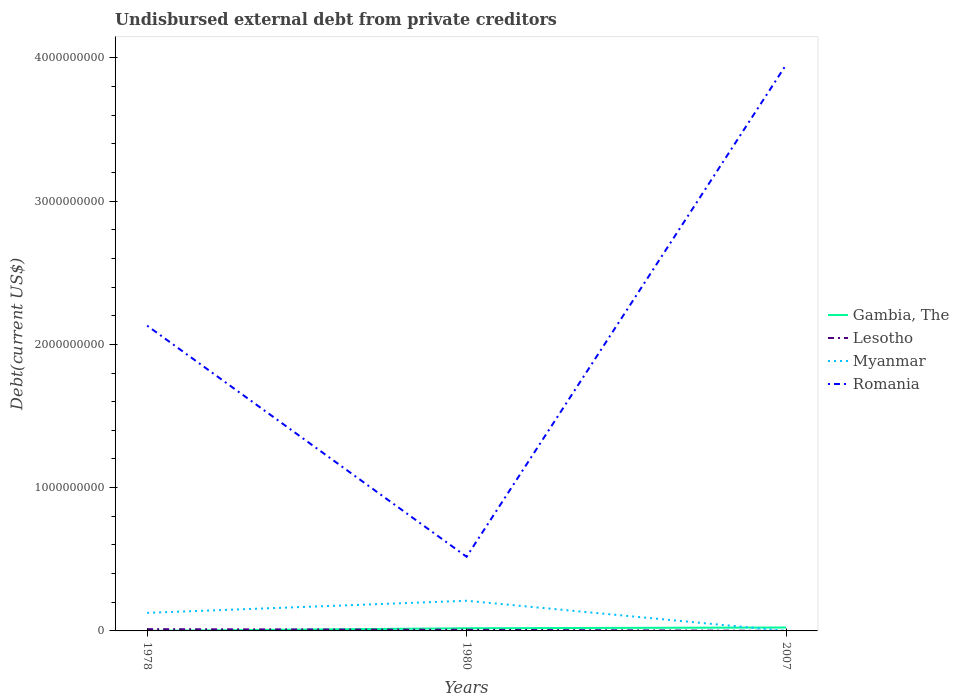How many different coloured lines are there?
Give a very brief answer. 4. Does the line corresponding to Myanmar intersect with the line corresponding to Lesotho?
Offer a terse response. Yes. Is the number of lines equal to the number of legend labels?
Offer a terse response. Yes. Across all years, what is the maximum total debt in Gambia, The?
Your response must be concise. 4.86e+05. In which year was the total debt in Lesotho maximum?
Offer a very short reply. 2007. What is the total total debt in Gambia, The in the graph?
Give a very brief answer. -2.34e+07. What is the difference between the highest and the second highest total debt in Lesotho?
Keep it short and to the point. 1.19e+07. Is the total debt in Gambia, The strictly greater than the total debt in Romania over the years?
Give a very brief answer. Yes. How many lines are there?
Keep it short and to the point. 4. What is the difference between two consecutive major ticks on the Y-axis?
Your response must be concise. 1.00e+09. Are the values on the major ticks of Y-axis written in scientific E-notation?
Keep it short and to the point. No. Where does the legend appear in the graph?
Your response must be concise. Center right. How many legend labels are there?
Keep it short and to the point. 4. How are the legend labels stacked?
Provide a short and direct response. Vertical. What is the title of the graph?
Your response must be concise. Undisbursed external debt from private creditors. What is the label or title of the X-axis?
Give a very brief answer. Years. What is the label or title of the Y-axis?
Provide a short and direct response. Debt(current US$). What is the Debt(current US$) in Gambia, The in 1978?
Your answer should be very brief. 4.86e+05. What is the Debt(current US$) of Lesotho in 1978?
Offer a terse response. 1.23e+07. What is the Debt(current US$) of Myanmar in 1978?
Give a very brief answer. 1.26e+08. What is the Debt(current US$) in Romania in 1978?
Make the answer very short. 2.13e+09. What is the Debt(current US$) in Gambia, The in 1980?
Provide a succinct answer. 1.86e+07. What is the Debt(current US$) in Myanmar in 1980?
Make the answer very short. 2.10e+08. What is the Debt(current US$) in Romania in 1980?
Your answer should be very brief. 5.18e+08. What is the Debt(current US$) in Gambia, The in 2007?
Provide a succinct answer. 2.39e+07. What is the Debt(current US$) in Lesotho in 2007?
Your answer should be very brief. 4.05e+05. What is the Debt(current US$) of Myanmar in 2007?
Your answer should be very brief. 4.70e+04. What is the Debt(current US$) in Romania in 2007?
Your answer should be compact. 3.95e+09. Across all years, what is the maximum Debt(current US$) in Gambia, The?
Keep it short and to the point. 2.39e+07. Across all years, what is the maximum Debt(current US$) of Lesotho?
Your response must be concise. 1.23e+07. Across all years, what is the maximum Debt(current US$) in Myanmar?
Offer a very short reply. 2.10e+08. Across all years, what is the maximum Debt(current US$) of Romania?
Keep it short and to the point. 3.95e+09. Across all years, what is the minimum Debt(current US$) of Gambia, The?
Your answer should be compact. 4.86e+05. Across all years, what is the minimum Debt(current US$) in Lesotho?
Keep it short and to the point. 4.05e+05. Across all years, what is the minimum Debt(current US$) of Myanmar?
Your answer should be compact. 4.70e+04. Across all years, what is the minimum Debt(current US$) in Romania?
Offer a very short reply. 5.18e+08. What is the total Debt(current US$) in Gambia, The in the graph?
Make the answer very short. 4.30e+07. What is the total Debt(current US$) in Lesotho in the graph?
Your response must be concise. 2.07e+07. What is the total Debt(current US$) of Myanmar in the graph?
Your answer should be very brief. 3.37e+08. What is the total Debt(current US$) of Romania in the graph?
Offer a terse response. 6.60e+09. What is the difference between the Debt(current US$) of Gambia, The in 1978 and that in 1980?
Keep it short and to the point. -1.81e+07. What is the difference between the Debt(current US$) of Lesotho in 1978 and that in 1980?
Provide a short and direct response. 4.29e+06. What is the difference between the Debt(current US$) in Myanmar in 1978 and that in 1980?
Provide a succinct answer. -8.45e+07. What is the difference between the Debt(current US$) of Romania in 1978 and that in 1980?
Make the answer very short. 1.61e+09. What is the difference between the Debt(current US$) of Gambia, The in 1978 and that in 2007?
Your response must be concise. -2.34e+07. What is the difference between the Debt(current US$) of Lesotho in 1978 and that in 2007?
Your answer should be very brief. 1.19e+07. What is the difference between the Debt(current US$) in Myanmar in 1978 and that in 2007?
Make the answer very short. 1.26e+08. What is the difference between the Debt(current US$) of Romania in 1978 and that in 2007?
Offer a terse response. -1.82e+09. What is the difference between the Debt(current US$) of Gambia, The in 1980 and that in 2007?
Provide a succinct answer. -5.34e+06. What is the difference between the Debt(current US$) in Lesotho in 1980 and that in 2007?
Your answer should be compact. 7.60e+06. What is the difference between the Debt(current US$) in Myanmar in 1980 and that in 2007?
Give a very brief answer. 2.10e+08. What is the difference between the Debt(current US$) of Romania in 1980 and that in 2007?
Make the answer very short. -3.43e+09. What is the difference between the Debt(current US$) of Gambia, The in 1978 and the Debt(current US$) of Lesotho in 1980?
Ensure brevity in your answer.  -7.51e+06. What is the difference between the Debt(current US$) in Gambia, The in 1978 and the Debt(current US$) in Myanmar in 1980?
Offer a very short reply. -2.10e+08. What is the difference between the Debt(current US$) in Gambia, The in 1978 and the Debt(current US$) in Romania in 1980?
Make the answer very short. -5.17e+08. What is the difference between the Debt(current US$) of Lesotho in 1978 and the Debt(current US$) of Myanmar in 1980?
Your response must be concise. -1.98e+08. What is the difference between the Debt(current US$) of Lesotho in 1978 and the Debt(current US$) of Romania in 1980?
Offer a very short reply. -5.05e+08. What is the difference between the Debt(current US$) in Myanmar in 1978 and the Debt(current US$) in Romania in 1980?
Offer a very short reply. -3.92e+08. What is the difference between the Debt(current US$) of Gambia, The in 1978 and the Debt(current US$) of Lesotho in 2007?
Ensure brevity in your answer.  8.10e+04. What is the difference between the Debt(current US$) in Gambia, The in 1978 and the Debt(current US$) in Myanmar in 2007?
Ensure brevity in your answer.  4.39e+05. What is the difference between the Debt(current US$) of Gambia, The in 1978 and the Debt(current US$) of Romania in 2007?
Your answer should be compact. -3.95e+09. What is the difference between the Debt(current US$) of Lesotho in 1978 and the Debt(current US$) of Myanmar in 2007?
Your response must be concise. 1.22e+07. What is the difference between the Debt(current US$) of Lesotho in 1978 and the Debt(current US$) of Romania in 2007?
Provide a succinct answer. -3.94e+09. What is the difference between the Debt(current US$) of Myanmar in 1978 and the Debt(current US$) of Romania in 2007?
Offer a terse response. -3.82e+09. What is the difference between the Debt(current US$) in Gambia, The in 1980 and the Debt(current US$) in Lesotho in 2007?
Provide a succinct answer. 1.82e+07. What is the difference between the Debt(current US$) in Gambia, The in 1980 and the Debt(current US$) in Myanmar in 2007?
Offer a terse response. 1.85e+07. What is the difference between the Debt(current US$) of Gambia, The in 1980 and the Debt(current US$) of Romania in 2007?
Offer a very short reply. -3.93e+09. What is the difference between the Debt(current US$) in Lesotho in 1980 and the Debt(current US$) in Myanmar in 2007?
Offer a very short reply. 7.95e+06. What is the difference between the Debt(current US$) of Lesotho in 1980 and the Debt(current US$) of Romania in 2007?
Keep it short and to the point. -3.94e+09. What is the difference between the Debt(current US$) in Myanmar in 1980 and the Debt(current US$) in Romania in 2007?
Ensure brevity in your answer.  -3.74e+09. What is the average Debt(current US$) in Gambia, The per year?
Make the answer very short. 1.43e+07. What is the average Debt(current US$) of Lesotho per year?
Provide a short and direct response. 6.90e+06. What is the average Debt(current US$) of Myanmar per year?
Ensure brevity in your answer.  1.12e+08. What is the average Debt(current US$) in Romania per year?
Ensure brevity in your answer.  2.20e+09. In the year 1978, what is the difference between the Debt(current US$) of Gambia, The and Debt(current US$) of Lesotho?
Your answer should be compact. -1.18e+07. In the year 1978, what is the difference between the Debt(current US$) of Gambia, The and Debt(current US$) of Myanmar?
Your answer should be compact. -1.26e+08. In the year 1978, what is the difference between the Debt(current US$) of Gambia, The and Debt(current US$) of Romania?
Make the answer very short. -2.13e+09. In the year 1978, what is the difference between the Debt(current US$) in Lesotho and Debt(current US$) in Myanmar?
Give a very brief answer. -1.14e+08. In the year 1978, what is the difference between the Debt(current US$) of Lesotho and Debt(current US$) of Romania?
Your answer should be compact. -2.12e+09. In the year 1978, what is the difference between the Debt(current US$) of Myanmar and Debt(current US$) of Romania?
Make the answer very short. -2.00e+09. In the year 1980, what is the difference between the Debt(current US$) in Gambia, The and Debt(current US$) in Lesotho?
Make the answer very short. 1.06e+07. In the year 1980, what is the difference between the Debt(current US$) of Gambia, The and Debt(current US$) of Myanmar?
Make the answer very short. -1.92e+08. In the year 1980, what is the difference between the Debt(current US$) of Gambia, The and Debt(current US$) of Romania?
Provide a short and direct response. -4.99e+08. In the year 1980, what is the difference between the Debt(current US$) of Lesotho and Debt(current US$) of Myanmar?
Give a very brief answer. -2.02e+08. In the year 1980, what is the difference between the Debt(current US$) in Lesotho and Debt(current US$) in Romania?
Ensure brevity in your answer.  -5.10e+08. In the year 1980, what is the difference between the Debt(current US$) of Myanmar and Debt(current US$) of Romania?
Your response must be concise. -3.07e+08. In the year 2007, what is the difference between the Debt(current US$) of Gambia, The and Debt(current US$) of Lesotho?
Keep it short and to the point. 2.35e+07. In the year 2007, what is the difference between the Debt(current US$) in Gambia, The and Debt(current US$) in Myanmar?
Ensure brevity in your answer.  2.39e+07. In the year 2007, what is the difference between the Debt(current US$) of Gambia, The and Debt(current US$) of Romania?
Make the answer very short. -3.93e+09. In the year 2007, what is the difference between the Debt(current US$) in Lesotho and Debt(current US$) in Myanmar?
Offer a terse response. 3.58e+05. In the year 2007, what is the difference between the Debt(current US$) in Lesotho and Debt(current US$) in Romania?
Offer a terse response. -3.95e+09. In the year 2007, what is the difference between the Debt(current US$) of Myanmar and Debt(current US$) of Romania?
Provide a short and direct response. -3.95e+09. What is the ratio of the Debt(current US$) of Gambia, The in 1978 to that in 1980?
Provide a short and direct response. 0.03. What is the ratio of the Debt(current US$) of Lesotho in 1978 to that in 1980?
Give a very brief answer. 1.54. What is the ratio of the Debt(current US$) in Myanmar in 1978 to that in 1980?
Offer a very short reply. 0.6. What is the ratio of the Debt(current US$) in Romania in 1978 to that in 1980?
Your answer should be very brief. 4.12. What is the ratio of the Debt(current US$) in Gambia, The in 1978 to that in 2007?
Your answer should be compact. 0.02. What is the ratio of the Debt(current US$) in Lesotho in 1978 to that in 2007?
Ensure brevity in your answer.  30.35. What is the ratio of the Debt(current US$) of Myanmar in 1978 to that in 2007?
Keep it short and to the point. 2680.96. What is the ratio of the Debt(current US$) in Romania in 1978 to that in 2007?
Make the answer very short. 0.54. What is the ratio of the Debt(current US$) of Gambia, The in 1980 to that in 2007?
Offer a terse response. 0.78. What is the ratio of the Debt(current US$) of Lesotho in 1980 to that in 2007?
Give a very brief answer. 19.75. What is the ratio of the Debt(current US$) of Myanmar in 1980 to that in 2007?
Provide a succinct answer. 4477.87. What is the ratio of the Debt(current US$) in Romania in 1980 to that in 2007?
Provide a short and direct response. 0.13. What is the difference between the highest and the second highest Debt(current US$) in Gambia, The?
Provide a short and direct response. 5.34e+06. What is the difference between the highest and the second highest Debt(current US$) in Lesotho?
Keep it short and to the point. 4.29e+06. What is the difference between the highest and the second highest Debt(current US$) of Myanmar?
Offer a very short reply. 8.45e+07. What is the difference between the highest and the second highest Debt(current US$) in Romania?
Provide a succinct answer. 1.82e+09. What is the difference between the highest and the lowest Debt(current US$) in Gambia, The?
Ensure brevity in your answer.  2.34e+07. What is the difference between the highest and the lowest Debt(current US$) in Lesotho?
Your answer should be very brief. 1.19e+07. What is the difference between the highest and the lowest Debt(current US$) in Myanmar?
Ensure brevity in your answer.  2.10e+08. What is the difference between the highest and the lowest Debt(current US$) in Romania?
Your response must be concise. 3.43e+09. 